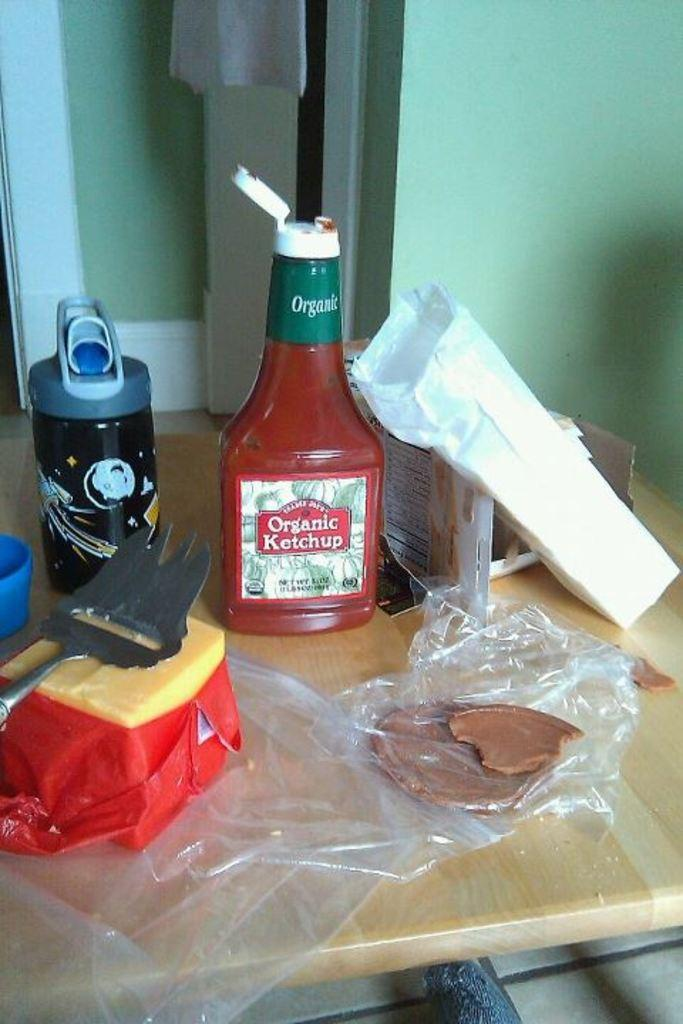<image>
Share a concise interpretation of the image provided. Organic Ketchup and other types of foods that are being made. 